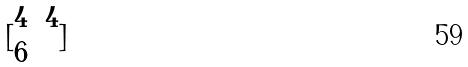<formula> <loc_0><loc_0><loc_500><loc_500>[ \begin{matrix} 4 & 4 \\ 6 \end{matrix} ]</formula> 